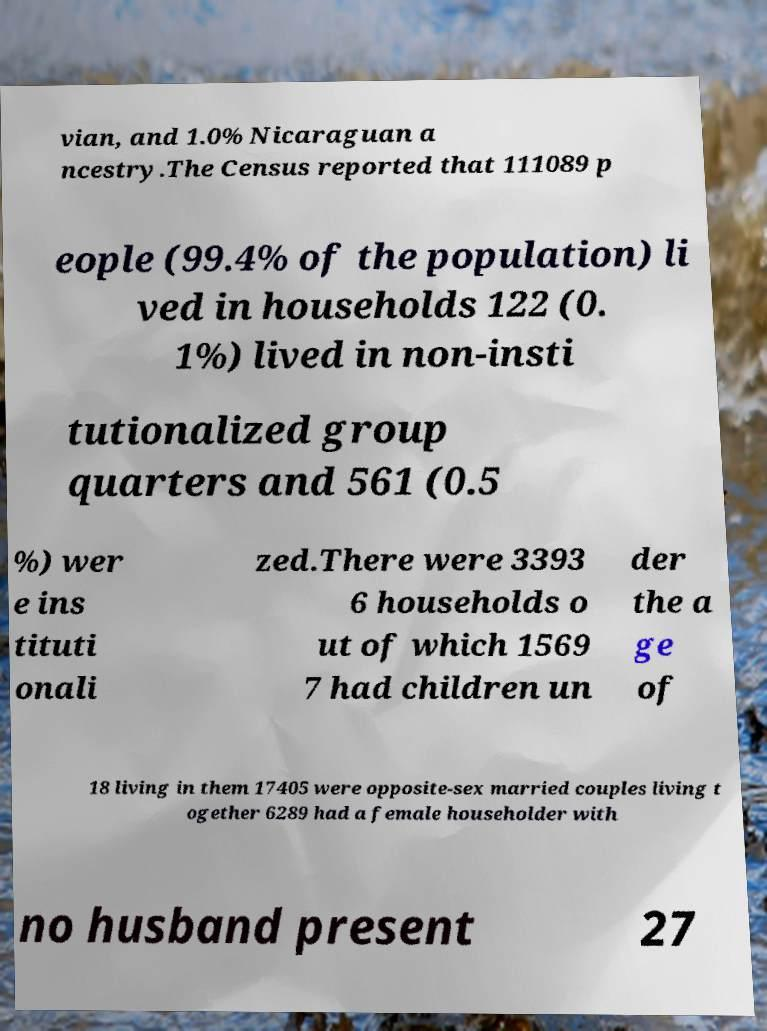Could you extract and type out the text from this image? vian, and 1.0% Nicaraguan a ncestry.The Census reported that 111089 p eople (99.4% of the population) li ved in households 122 (0. 1%) lived in non-insti tutionalized group quarters and 561 (0.5 %) wer e ins tituti onali zed.There were 3393 6 households o ut of which 1569 7 had children un der the a ge of 18 living in them 17405 were opposite-sex married couples living t ogether 6289 had a female householder with no husband present 27 